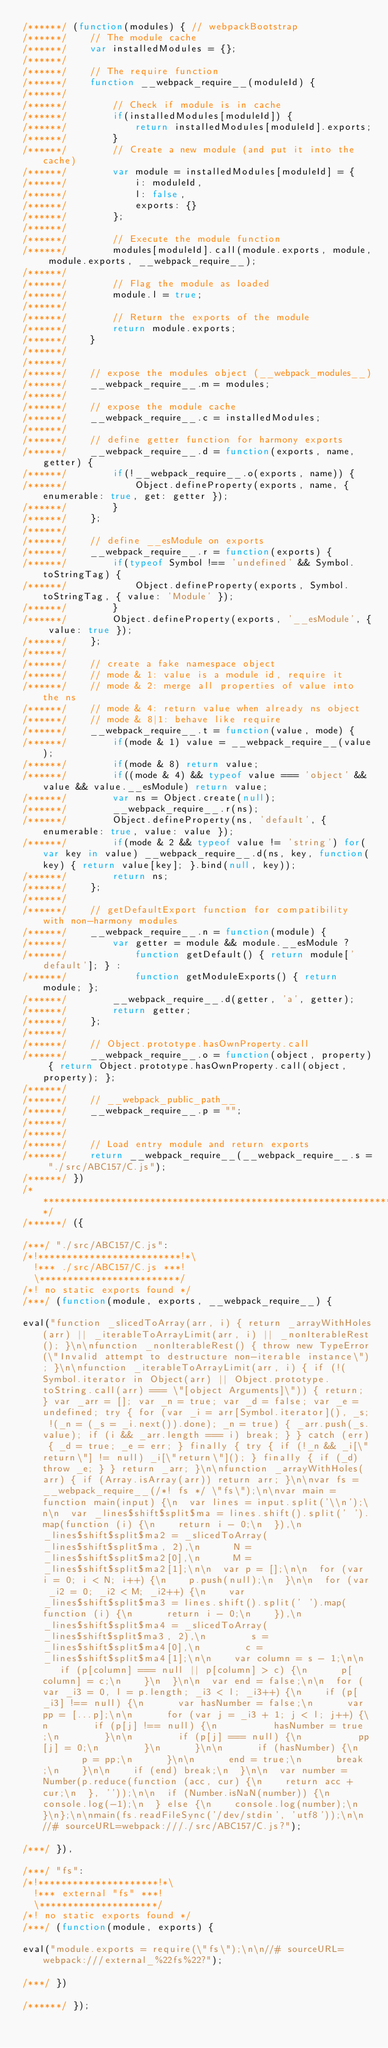<code> <loc_0><loc_0><loc_500><loc_500><_JavaScript_>/******/ (function(modules) { // webpackBootstrap
/******/ 	// The module cache
/******/ 	var installedModules = {};
/******/
/******/ 	// The require function
/******/ 	function __webpack_require__(moduleId) {
/******/
/******/ 		// Check if module is in cache
/******/ 		if(installedModules[moduleId]) {
/******/ 			return installedModules[moduleId].exports;
/******/ 		}
/******/ 		// Create a new module (and put it into the cache)
/******/ 		var module = installedModules[moduleId] = {
/******/ 			i: moduleId,
/******/ 			l: false,
/******/ 			exports: {}
/******/ 		};
/******/
/******/ 		// Execute the module function
/******/ 		modules[moduleId].call(module.exports, module, module.exports, __webpack_require__);
/******/
/******/ 		// Flag the module as loaded
/******/ 		module.l = true;
/******/
/******/ 		// Return the exports of the module
/******/ 		return module.exports;
/******/ 	}
/******/
/******/
/******/ 	// expose the modules object (__webpack_modules__)
/******/ 	__webpack_require__.m = modules;
/******/
/******/ 	// expose the module cache
/******/ 	__webpack_require__.c = installedModules;
/******/
/******/ 	// define getter function for harmony exports
/******/ 	__webpack_require__.d = function(exports, name, getter) {
/******/ 		if(!__webpack_require__.o(exports, name)) {
/******/ 			Object.defineProperty(exports, name, { enumerable: true, get: getter });
/******/ 		}
/******/ 	};
/******/
/******/ 	// define __esModule on exports
/******/ 	__webpack_require__.r = function(exports) {
/******/ 		if(typeof Symbol !== 'undefined' && Symbol.toStringTag) {
/******/ 			Object.defineProperty(exports, Symbol.toStringTag, { value: 'Module' });
/******/ 		}
/******/ 		Object.defineProperty(exports, '__esModule', { value: true });
/******/ 	};
/******/
/******/ 	// create a fake namespace object
/******/ 	// mode & 1: value is a module id, require it
/******/ 	// mode & 2: merge all properties of value into the ns
/******/ 	// mode & 4: return value when already ns object
/******/ 	// mode & 8|1: behave like require
/******/ 	__webpack_require__.t = function(value, mode) {
/******/ 		if(mode & 1) value = __webpack_require__(value);
/******/ 		if(mode & 8) return value;
/******/ 		if((mode & 4) && typeof value === 'object' && value && value.__esModule) return value;
/******/ 		var ns = Object.create(null);
/******/ 		__webpack_require__.r(ns);
/******/ 		Object.defineProperty(ns, 'default', { enumerable: true, value: value });
/******/ 		if(mode & 2 && typeof value != 'string') for(var key in value) __webpack_require__.d(ns, key, function(key) { return value[key]; }.bind(null, key));
/******/ 		return ns;
/******/ 	};
/******/
/******/ 	// getDefaultExport function for compatibility with non-harmony modules
/******/ 	__webpack_require__.n = function(module) {
/******/ 		var getter = module && module.__esModule ?
/******/ 			function getDefault() { return module['default']; } :
/******/ 			function getModuleExports() { return module; };
/******/ 		__webpack_require__.d(getter, 'a', getter);
/******/ 		return getter;
/******/ 	};
/******/
/******/ 	// Object.prototype.hasOwnProperty.call
/******/ 	__webpack_require__.o = function(object, property) { return Object.prototype.hasOwnProperty.call(object, property); };
/******/
/******/ 	// __webpack_public_path__
/******/ 	__webpack_require__.p = "";
/******/
/******/
/******/ 	// Load entry module and return exports
/******/ 	return __webpack_require__(__webpack_require__.s = "./src/ABC157/C.js");
/******/ })
/************************************************************************/
/******/ ({

/***/ "./src/ABC157/C.js":
/*!*************************!*\
  !*** ./src/ABC157/C.js ***!
  \*************************/
/*! no static exports found */
/***/ (function(module, exports, __webpack_require__) {

eval("function _slicedToArray(arr, i) { return _arrayWithHoles(arr) || _iterableToArrayLimit(arr, i) || _nonIterableRest(); }\n\nfunction _nonIterableRest() { throw new TypeError(\"Invalid attempt to destructure non-iterable instance\"); }\n\nfunction _iterableToArrayLimit(arr, i) { if (!(Symbol.iterator in Object(arr) || Object.prototype.toString.call(arr) === \"[object Arguments]\")) { return; } var _arr = []; var _n = true; var _d = false; var _e = undefined; try { for (var _i = arr[Symbol.iterator](), _s; !(_n = (_s = _i.next()).done); _n = true) { _arr.push(_s.value); if (i && _arr.length === i) break; } } catch (err) { _d = true; _e = err; } finally { try { if (!_n && _i[\"return\"] != null) _i[\"return\"](); } finally { if (_d) throw _e; } } return _arr; }\n\nfunction _arrayWithHoles(arr) { if (Array.isArray(arr)) return arr; }\n\nvar fs = __webpack_require__(/*! fs */ \"fs\");\n\nvar main = function main(input) {\n  var lines = input.split('\\n');\n\n  var _lines$shift$split$ma = lines.shift().split(' ').map(function (i) {\n    return i - 0;\n  }),\n      _lines$shift$split$ma2 = _slicedToArray(_lines$shift$split$ma, 2),\n      N = _lines$shift$split$ma2[0],\n      M = _lines$shift$split$ma2[1];\n\n  var p = [];\n\n  for (var i = 0; i < N; i++) {\n    p.push(null);\n  }\n\n  for (var _i2 = 0; _i2 < M; _i2++) {\n    var _lines$shift$split$ma3 = lines.shift().split(' ').map(function (i) {\n      return i - 0;\n    }),\n        _lines$shift$split$ma4 = _slicedToArray(_lines$shift$split$ma3, 2),\n        s = _lines$shift$split$ma4[0],\n        c = _lines$shift$split$ma4[1];\n\n    var column = s - 1;\n\n    if (p[column] === null || p[column] > c) {\n      p[column] = c;\n    }\n  }\n\n  var end = false;\n\n  for (var _i3 = 0, l = p.length; _i3 < l; _i3++) {\n    if (p[_i3] !== null) {\n      var hasNumber = false;\n      var pp = [...p];\n\n      for (var j = _i3 + 1; j < l; j++) {\n        if (p[j] !== null) {\n          hasNumber = true;\n        }\n\n        if (p[j] === null) {\n          pp[j] = 0;\n        }\n      }\n\n      if (hasNumber) {\n        p = pp;\n      }\n\n      end = true;\n      break;\n    }\n\n    if (end) break;\n  }\n\n  var number = Number(p.reduce(function (acc, cur) {\n    return acc + cur;\n  }, ''));\n\n  if (Number.isNaN(number)) {\n    console.log(-1);\n  } else {\n    console.log(number);\n  }\n};\n\nmain(fs.readFileSync('/dev/stdin', 'utf8'));\n\n//# sourceURL=webpack:///./src/ABC157/C.js?");

/***/ }),

/***/ "fs":
/*!*********************!*\
  !*** external "fs" ***!
  \*********************/
/*! no static exports found */
/***/ (function(module, exports) {

eval("module.exports = require(\"fs\");\n\n//# sourceURL=webpack:///external_%22fs%22?");

/***/ })

/******/ });</code> 